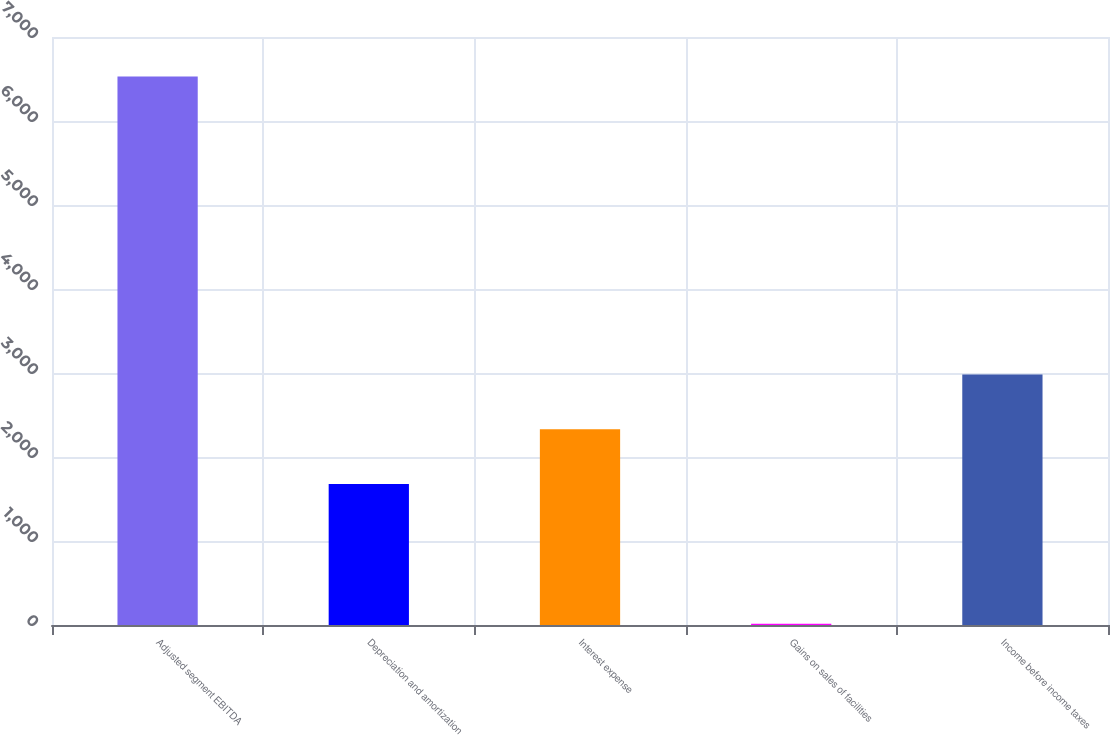<chart> <loc_0><loc_0><loc_500><loc_500><bar_chart><fcel>Adjusted segment EBITDA<fcel>Depreciation and amortization<fcel>Interest expense<fcel>Gains on sales of facilities<fcel>Income before income taxes<nl><fcel>6531<fcel>1679<fcel>2330.6<fcel>15<fcel>2982.2<nl></chart> 